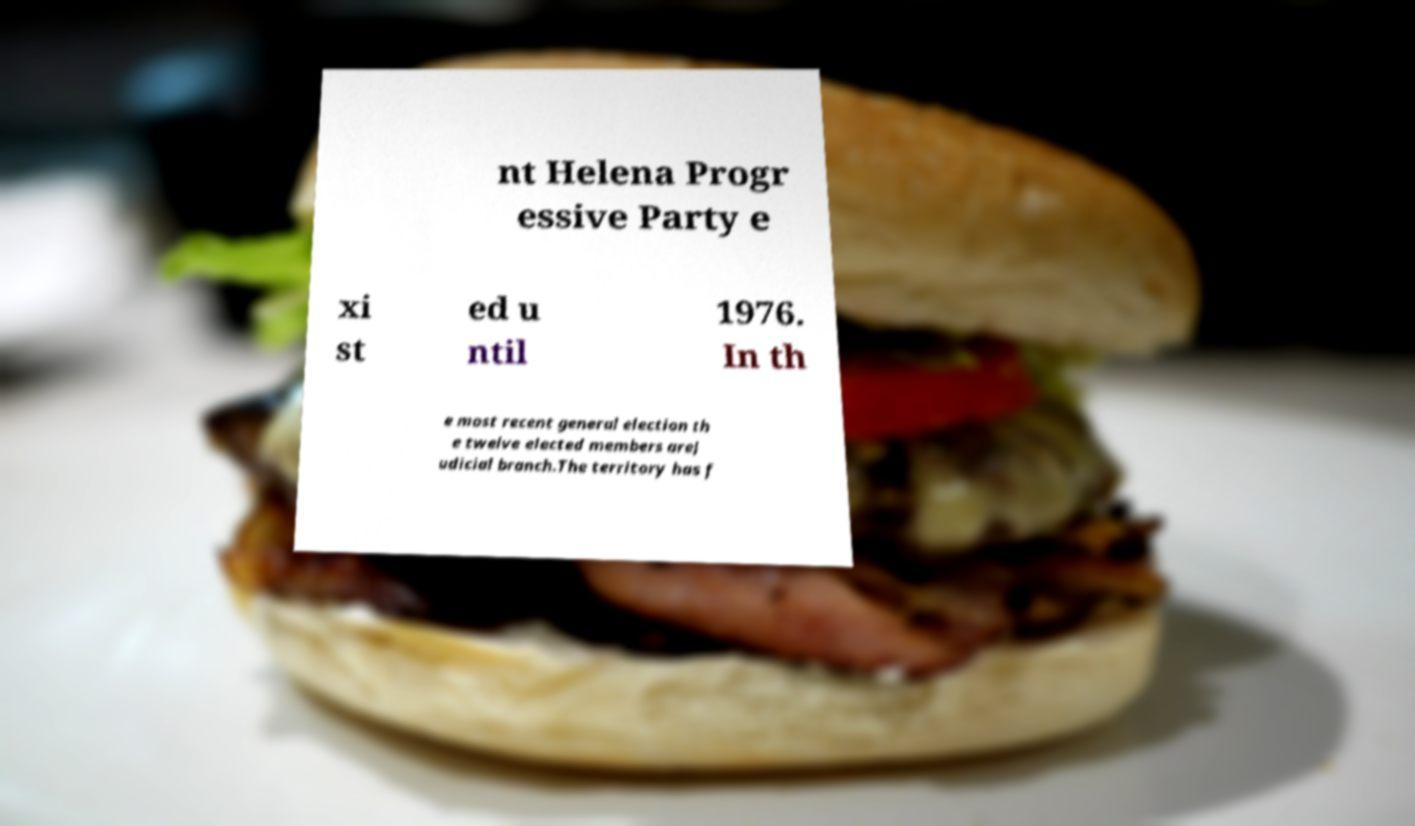For documentation purposes, I need the text within this image transcribed. Could you provide that? nt Helena Progr essive Party e xi st ed u ntil 1976. In th e most recent general election th e twelve elected members areJ udicial branch.The territory has f 